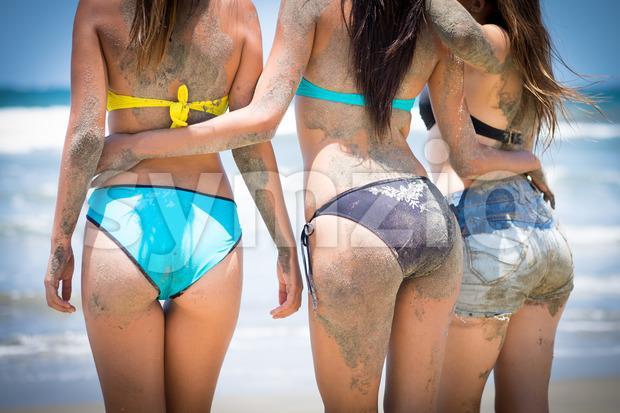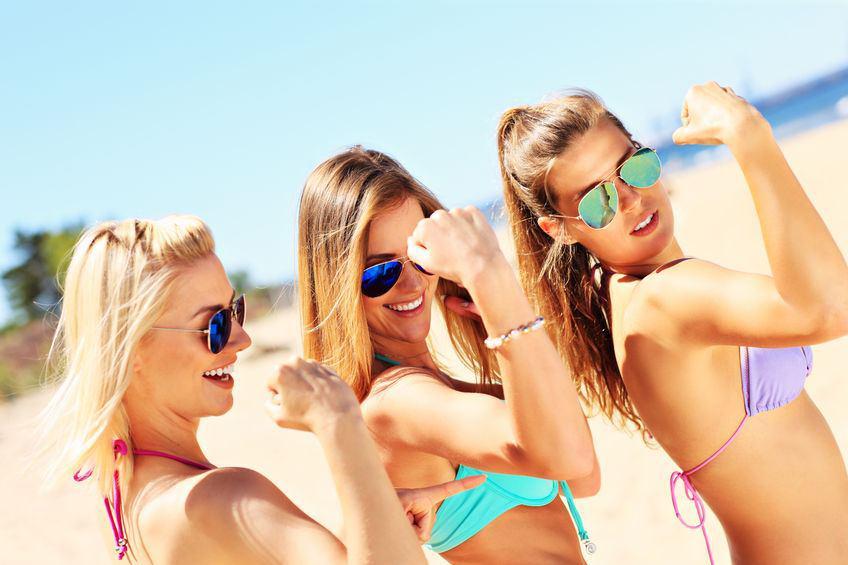The first image is the image on the left, the second image is the image on the right. Evaluate the accuracy of this statement regarding the images: "An image shows three rear-facing models, standing in front of water.". Is it true? Answer yes or no. Yes. The first image is the image on the left, the second image is the image on the right. Considering the images on both sides, is "In one image, the backsides of three women dressed in bikinis are visible" valid? Answer yes or no. Yes. 